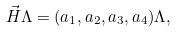Convert formula to latex. <formula><loc_0><loc_0><loc_500><loc_500>\vec { H } \Lambda = ( a _ { 1 } , a _ { 2 } , a _ { 3 } , a _ { 4 } ) \Lambda ,</formula> 